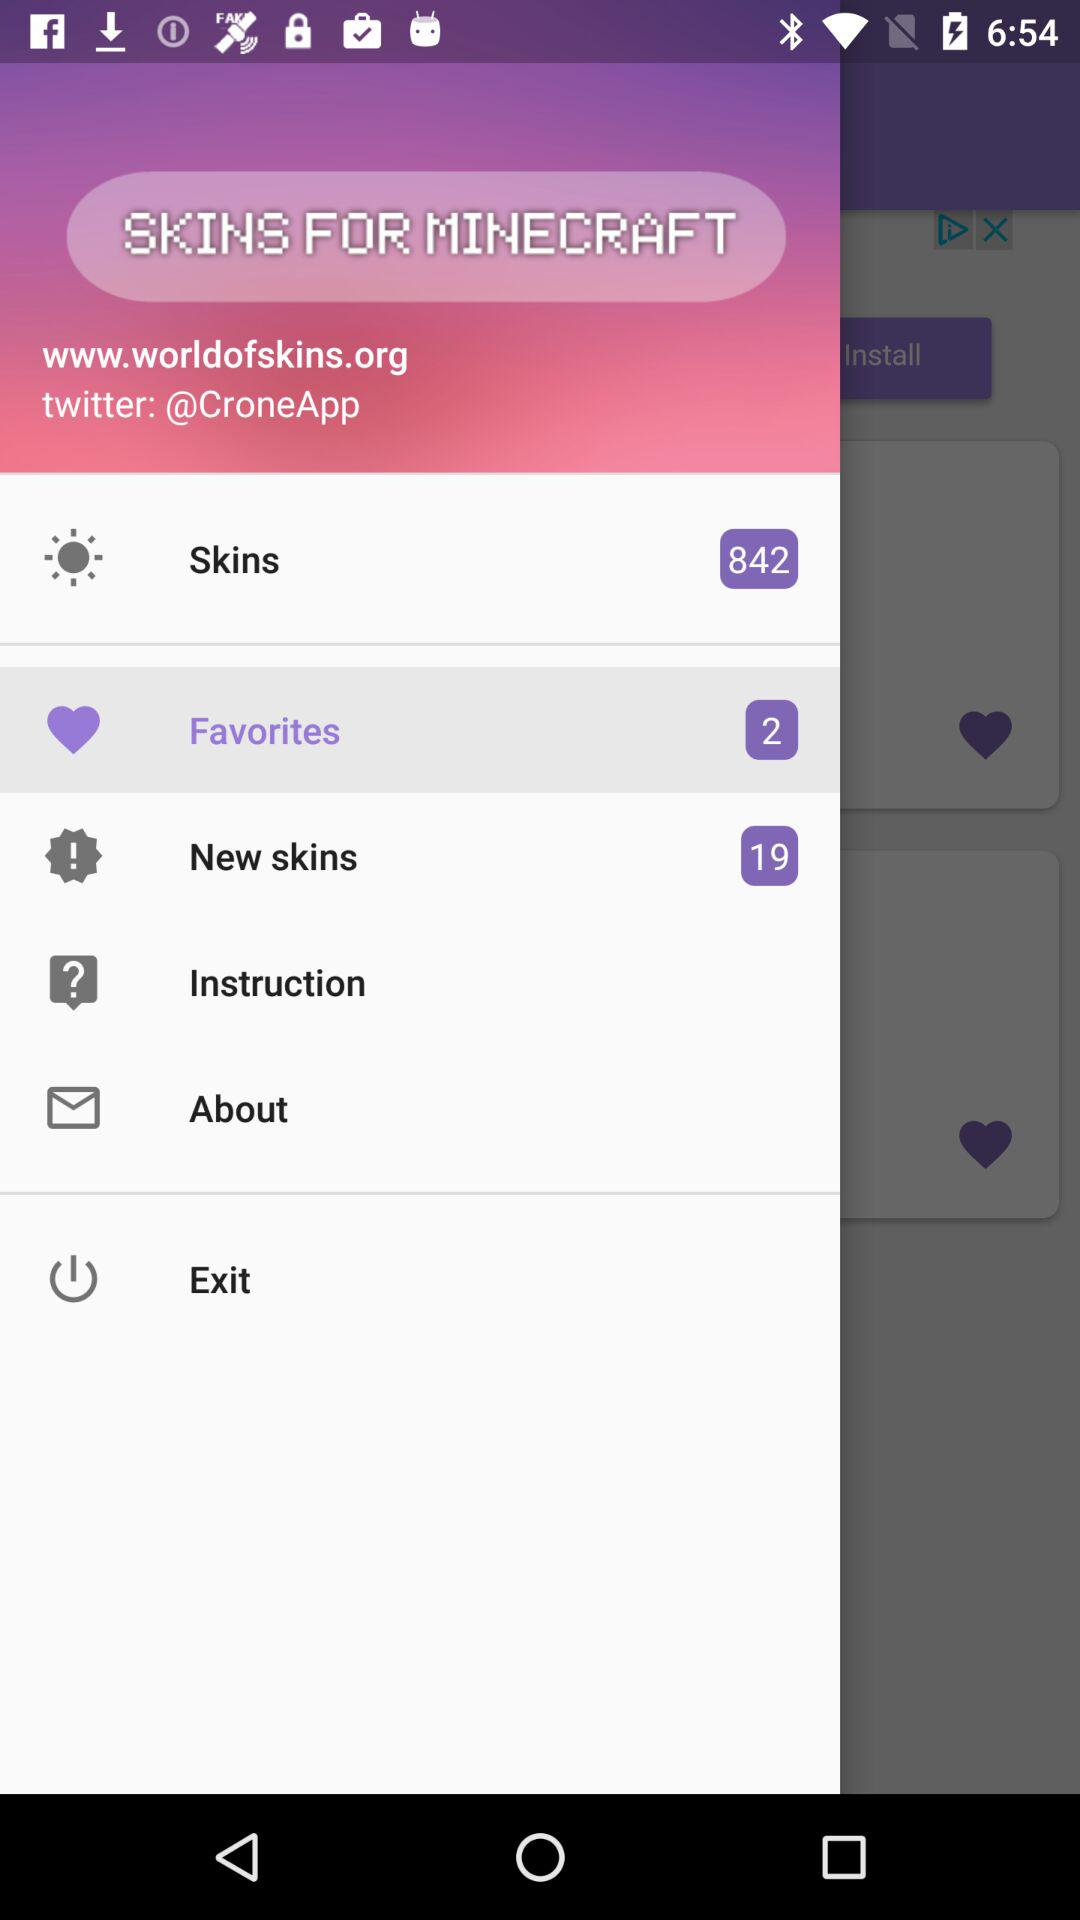How many items are there in "Favorites"? There are 2 items in "Favorites". 